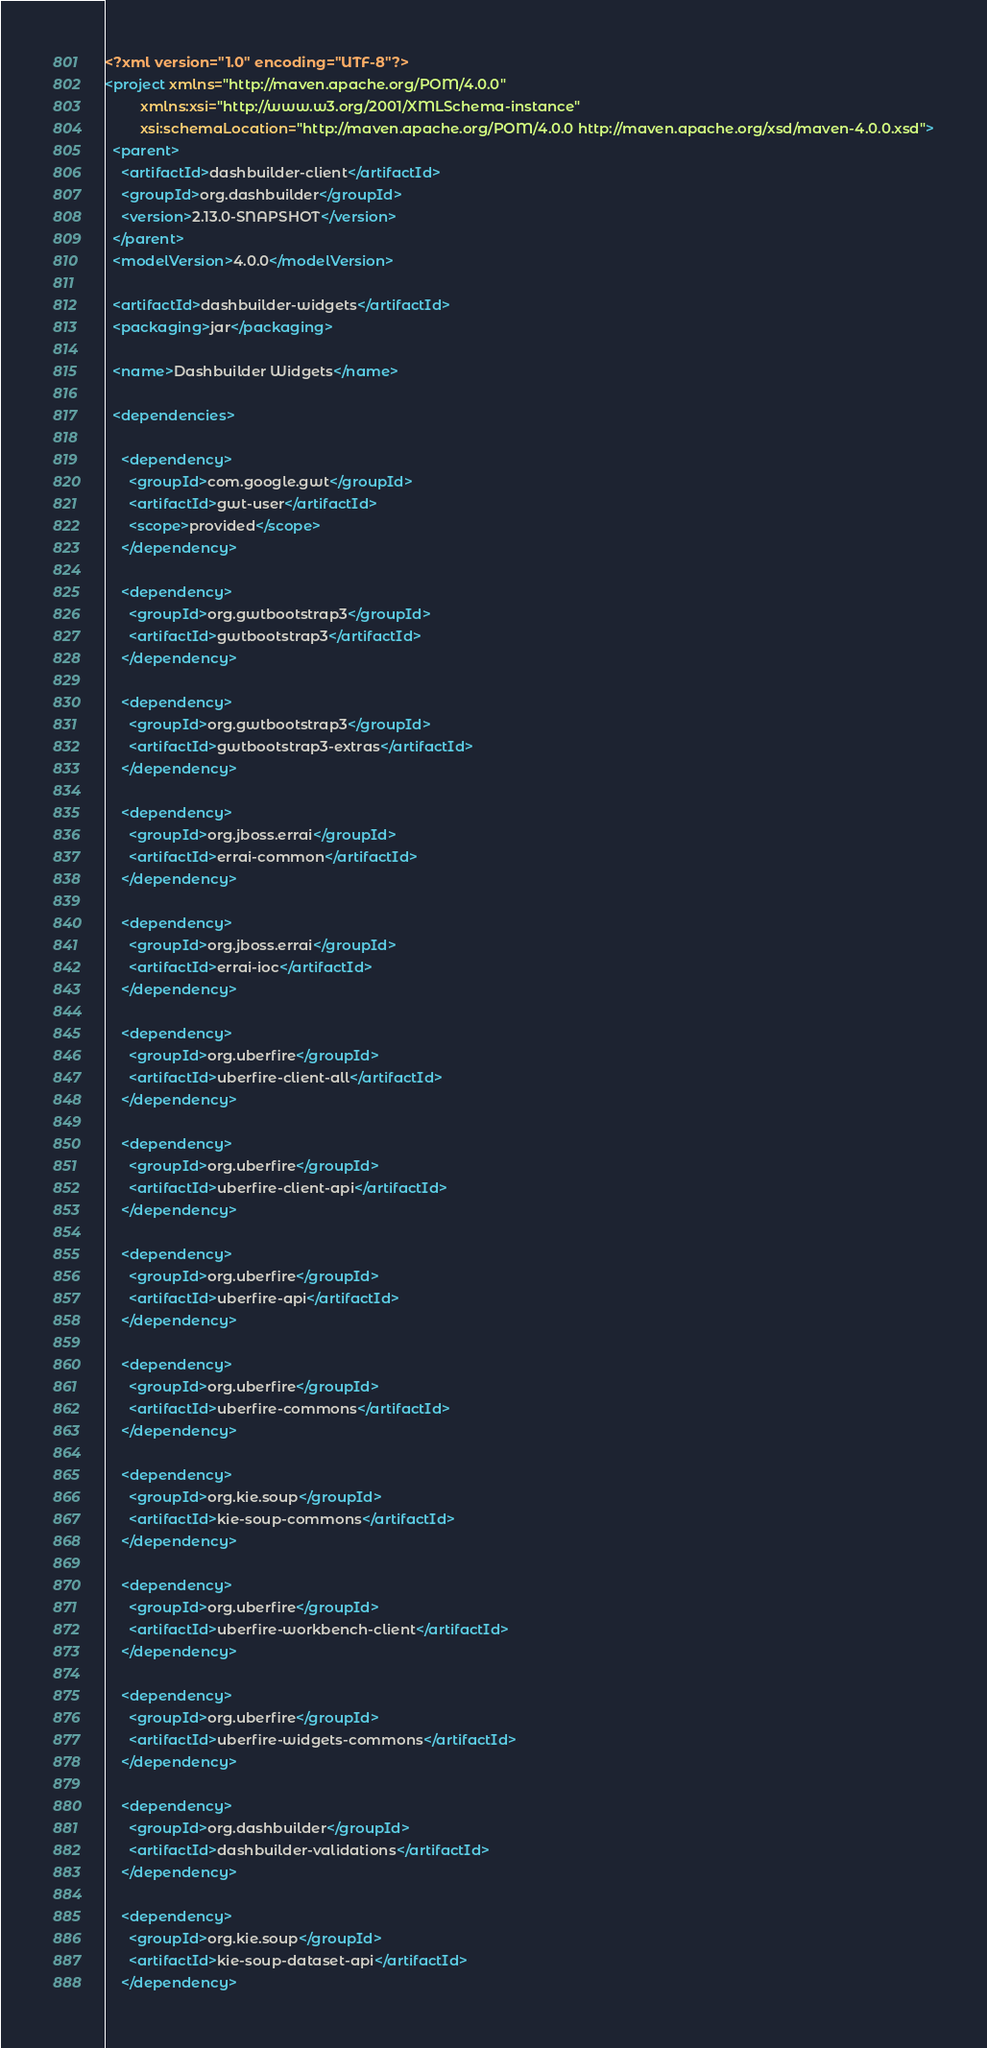Convert code to text. <code><loc_0><loc_0><loc_500><loc_500><_XML_><?xml version="1.0" encoding="UTF-8"?>
<project xmlns="http://maven.apache.org/POM/4.0.0"
         xmlns:xsi="http://www.w3.org/2001/XMLSchema-instance"
         xsi:schemaLocation="http://maven.apache.org/POM/4.0.0 http://maven.apache.org/xsd/maven-4.0.0.xsd">
  <parent>
    <artifactId>dashbuilder-client</artifactId>
    <groupId>org.dashbuilder</groupId>
    <version>2.13.0-SNAPSHOT</version>
  </parent>
  <modelVersion>4.0.0</modelVersion>

  <artifactId>dashbuilder-widgets</artifactId>
  <packaging>jar</packaging>

  <name>Dashbuilder Widgets</name>

  <dependencies>

    <dependency>
      <groupId>com.google.gwt</groupId>
      <artifactId>gwt-user</artifactId>
      <scope>provided</scope>
    </dependency>

    <dependency>
      <groupId>org.gwtbootstrap3</groupId>
      <artifactId>gwtbootstrap3</artifactId>
    </dependency>

    <dependency>
      <groupId>org.gwtbootstrap3</groupId>
      <artifactId>gwtbootstrap3-extras</artifactId>
    </dependency>

    <dependency>
      <groupId>org.jboss.errai</groupId>
      <artifactId>errai-common</artifactId>
    </dependency>

    <dependency>
      <groupId>org.jboss.errai</groupId>
      <artifactId>errai-ioc</artifactId>
    </dependency>

    <dependency>
      <groupId>org.uberfire</groupId>
      <artifactId>uberfire-client-all</artifactId>
    </dependency>

    <dependency>
      <groupId>org.uberfire</groupId>
      <artifactId>uberfire-client-api</artifactId>
    </dependency>

    <dependency>
      <groupId>org.uberfire</groupId>
      <artifactId>uberfire-api</artifactId>
    </dependency>

    <dependency>
      <groupId>org.uberfire</groupId>
      <artifactId>uberfire-commons</artifactId>
    </dependency>

    <dependency>
      <groupId>org.kie.soup</groupId>
      <artifactId>kie-soup-commons</artifactId>
    </dependency>

    <dependency>
      <groupId>org.uberfire</groupId>
      <artifactId>uberfire-workbench-client</artifactId>
    </dependency>

    <dependency>
      <groupId>org.uberfire</groupId>
      <artifactId>uberfire-widgets-commons</artifactId>
    </dependency>

    <dependency>
      <groupId>org.dashbuilder</groupId>
      <artifactId>dashbuilder-validations</artifactId>
    </dependency>

    <dependency>
      <groupId>org.kie.soup</groupId>
      <artifactId>kie-soup-dataset-api</artifactId>
    </dependency>
</code> 